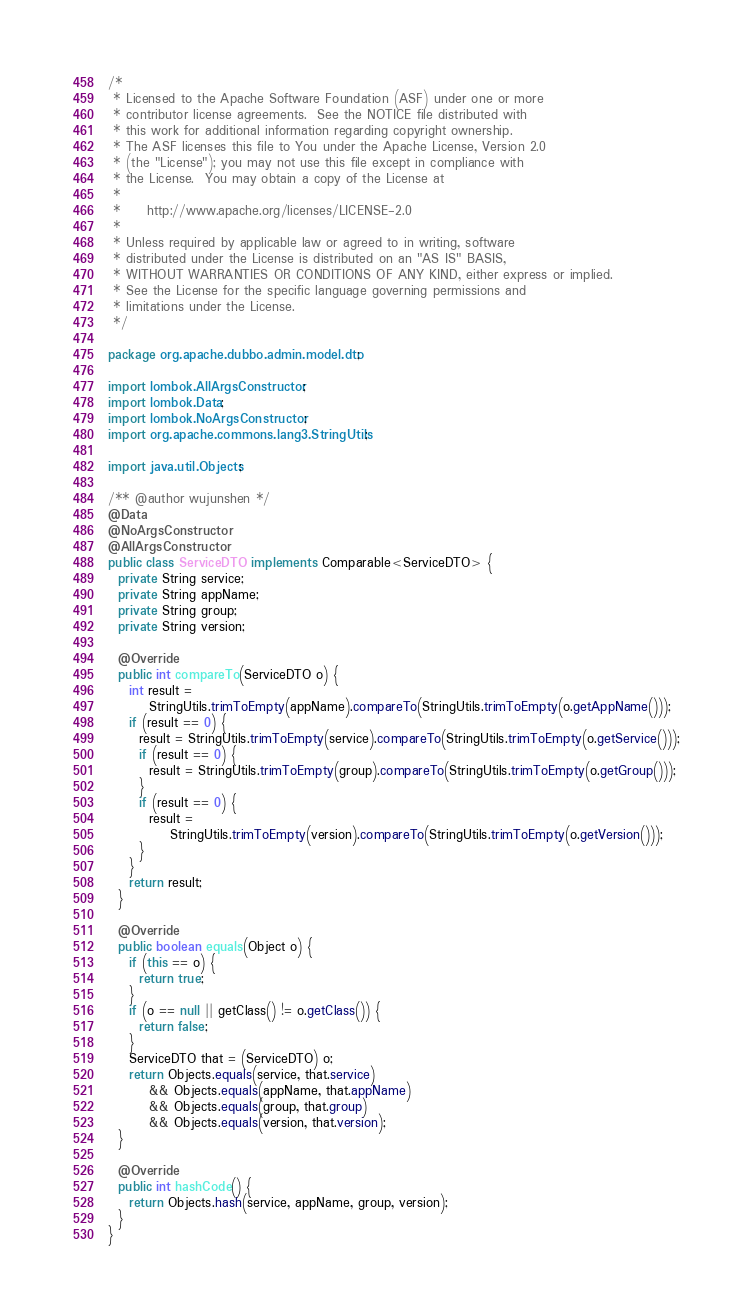Convert code to text. <code><loc_0><loc_0><loc_500><loc_500><_Java_>/*
 * Licensed to the Apache Software Foundation (ASF) under one or more
 * contributor license agreements.  See the NOTICE file distributed with
 * this work for additional information regarding copyright ownership.
 * The ASF licenses this file to You under the Apache License, Version 2.0
 * (the "License"); you may not use this file except in compliance with
 * the License.  You may obtain a copy of the License at
 *
 *     http://www.apache.org/licenses/LICENSE-2.0
 *
 * Unless required by applicable law or agreed to in writing, software
 * distributed under the License is distributed on an "AS IS" BASIS,
 * WITHOUT WARRANTIES OR CONDITIONS OF ANY KIND, either express or implied.
 * See the License for the specific language governing permissions and
 * limitations under the License.
 */

package org.apache.dubbo.admin.model.dto;

import lombok.AllArgsConstructor;
import lombok.Data;
import lombok.NoArgsConstructor;
import org.apache.commons.lang3.StringUtils;

import java.util.Objects;

/** @author wujunshen */
@Data
@NoArgsConstructor
@AllArgsConstructor
public class ServiceDTO implements Comparable<ServiceDTO> {
  private String service;
  private String appName;
  private String group;
  private String version;

  @Override
  public int compareTo(ServiceDTO o) {
    int result =
        StringUtils.trimToEmpty(appName).compareTo(StringUtils.trimToEmpty(o.getAppName()));
    if (result == 0) {
      result = StringUtils.trimToEmpty(service).compareTo(StringUtils.trimToEmpty(o.getService()));
      if (result == 0) {
        result = StringUtils.trimToEmpty(group).compareTo(StringUtils.trimToEmpty(o.getGroup()));
      }
      if (result == 0) {
        result =
            StringUtils.trimToEmpty(version).compareTo(StringUtils.trimToEmpty(o.getVersion()));
      }
    }
    return result;
  }

  @Override
  public boolean equals(Object o) {
    if (this == o) {
      return true;
    }
    if (o == null || getClass() != o.getClass()) {
      return false;
    }
    ServiceDTO that = (ServiceDTO) o;
    return Objects.equals(service, that.service)
        && Objects.equals(appName, that.appName)
        && Objects.equals(group, that.group)
        && Objects.equals(version, that.version);
  }

  @Override
  public int hashCode() {
    return Objects.hash(service, appName, group, version);
  }
}
</code> 